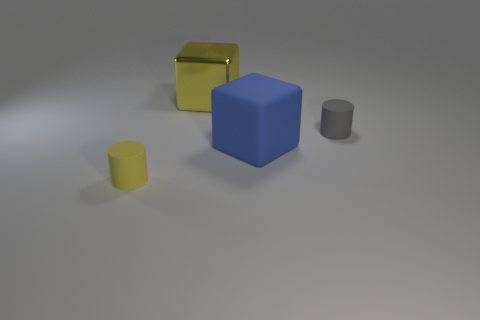What can you infer about the material of the large yellow object compared to the other objects? The large yellow object has a reflective surface, indicating that it may be made from a glossier material like plastic or metal, which contrasts with the matte finish of the other four objects. 